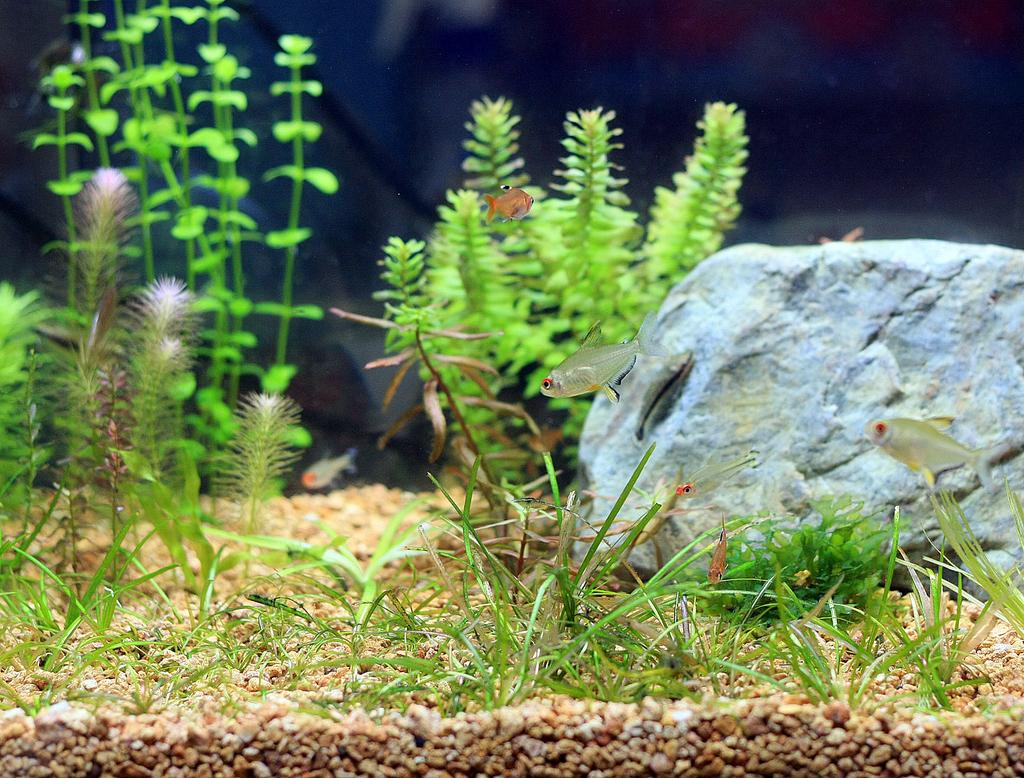What is the main object in the image? There is a stone in the image. What type of living organisms can be seen in the image? There are fishes in the image. What type of vegetation is present in the image? There is grass and water plants in the image. Can you describe the environment in the image? The image features a stone, fishes, grass, water plants, and stones at the bottom, suggesting a watery environment. What type of coastline can be seen in the image? There is no coastline visible in the image; it features a stone, fishes, grass, water plants, and stones at the bottom. What level of detail can be seen in the image? The level of detail in the image cannot be determined from the provided facts, as it depends on the resolution and quality of the image itself. 